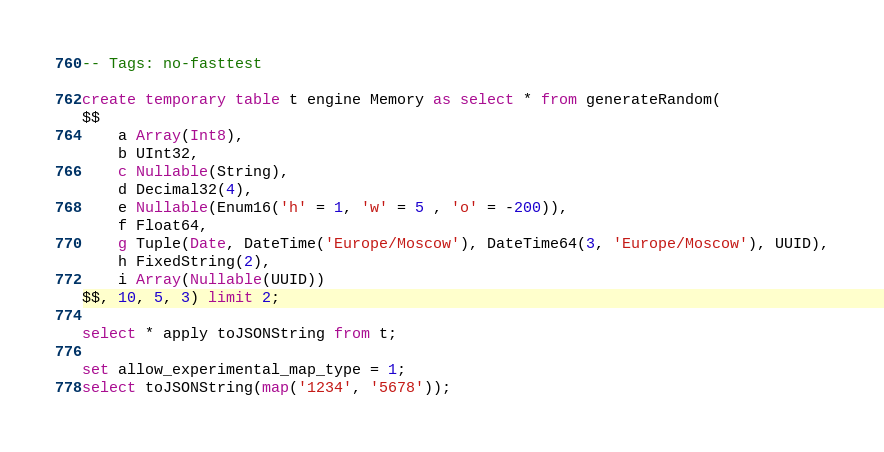<code> <loc_0><loc_0><loc_500><loc_500><_SQL_>-- Tags: no-fasttest

create temporary table t engine Memory as select * from generateRandom(
$$
    a Array(Int8),
    b UInt32,
    c Nullable(String),
    d Decimal32(4),
    e Nullable(Enum16('h' = 1, 'w' = 5 , 'o' = -200)),
    f Float64,
    g Tuple(Date, DateTime('Europe/Moscow'), DateTime64(3, 'Europe/Moscow'), UUID),
    h FixedString(2),
    i Array(Nullable(UUID))
$$, 10, 5, 3) limit 2;

select * apply toJSONString from t;

set allow_experimental_map_type = 1;
select toJSONString(map('1234', '5678'));
</code> 